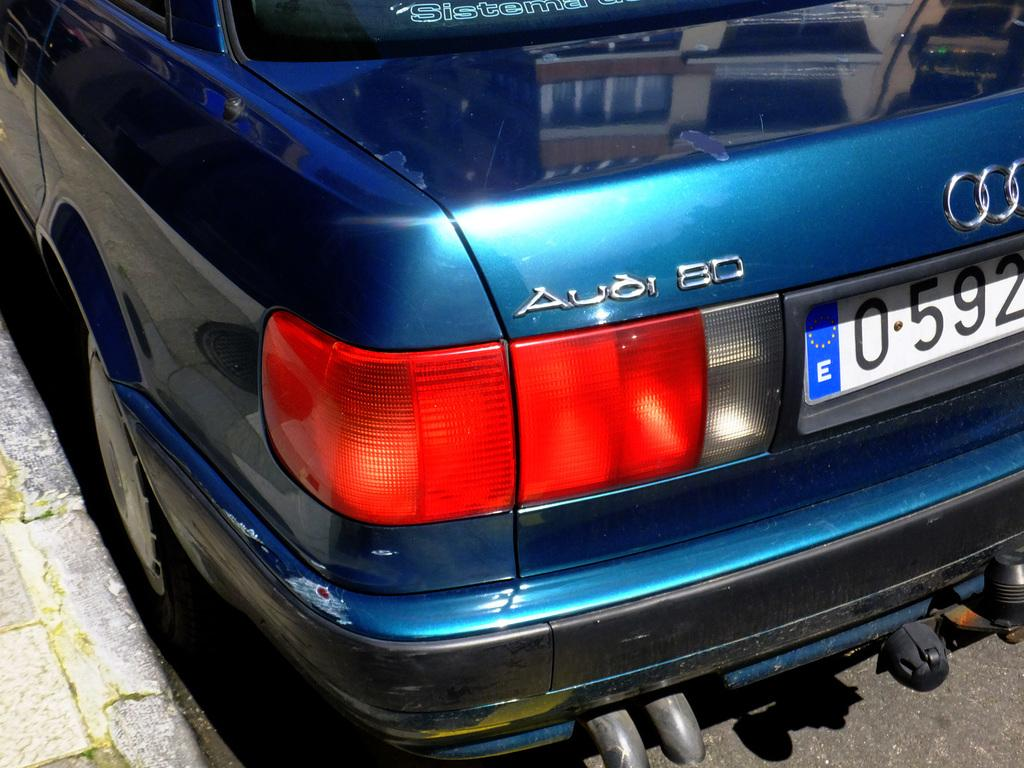What part of an Audi car can be seen in the image? The boot of an Audi car is visible in the image. Where is the car located in relation to other features? The car is beside a footpath. What is the color of the Audi car in the image? The car is blue in color. Can you tell me how many times the kettle has been used by an expert in the image? There is no kettle or expert present in the image. 